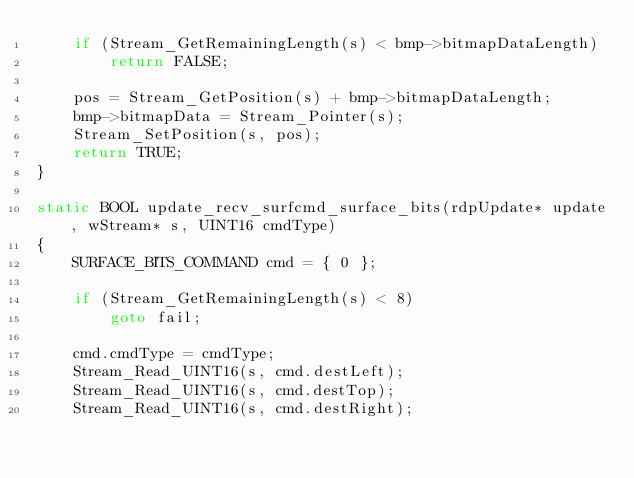<code> <loc_0><loc_0><loc_500><loc_500><_C_>	if (Stream_GetRemainingLength(s) < bmp->bitmapDataLength)
		return FALSE;

	pos = Stream_GetPosition(s) + bmp->bitmapDataLength;
	bmp->bitmapData = Stream_Pointer(s);
	Stream_SetPosition(s, pos);
	return TRUE;
}

static BOOL update_recv_surfcmd_surface_bits(rdpUpdate* update, wStream* s, UINT16 cmdType)
{
	SURFACE_BITS_COMMAND cmd = { 0 };

	if (Stream_GetRemainingLength(s) < 8)
		goto fail;

	cmd.cmdType = cmdType;
	Stream_Read_UINT16(s, cmd.destLeft);
	Stream_Read_UINT16(s, cmd.destTop);
	Stream_Read_UINT16(s, cmd.destRight);</code> 